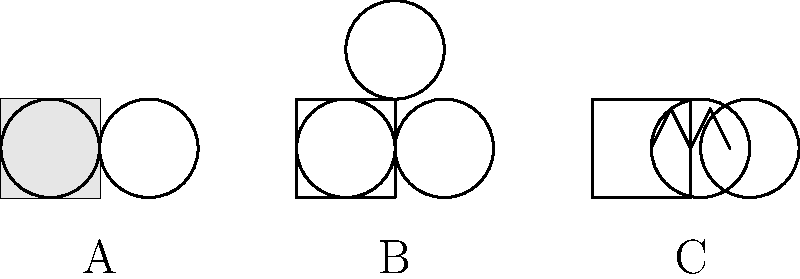Well, well, well! Looks like we've got ourselves a real "shocking" situation here. Can you identify these electrical outlets and their voltage ratings? And please, try not to get your wires crossed in the process! Alright, let's break this down for all you "current" affairs enthusiasts:

1. Outlet A: This is your standard 2-prong outlet. It's as basic as they come, like a light switch with delusions of grandeur. These bad boys typically run on 120V AC in North America. They're perfect for powering your TV remote when you're too lazy to change the batteries.

2. Outlet B: Now we're cooking with gas! This 3-prong outlet is what we call a grounded outlet. It's got that extra prong at the top, which is like a safety net for electricity. These also run on 120V AC in North America. It's what you use when you want to feel extra safe while blow-drying your hair in the bathtub (please don't).

3. Outlet C: Oh, fancy pants! This is a NEMA 6-15 outlet. It's got that distinctive T-shape that screams "I'm special!" This outlet is rated for 240V AC and is commonly used for larger appliances or power tools. It's what you plug in when you want to feel like Tim "The Tool Man" Taylor.

Now, the voltage ratings:
- 120V AC: Standard for most household items in North America. It's like the vanilla ice cream of voltages.
- 240V AC: Used for high-power appliances and tools. It's the double espresso of the voltage world.

Remember, kids: Just because you can stick a fork in it, doesn't mean you should!
Answer: A: 120V, B: 120V, C: 240V 